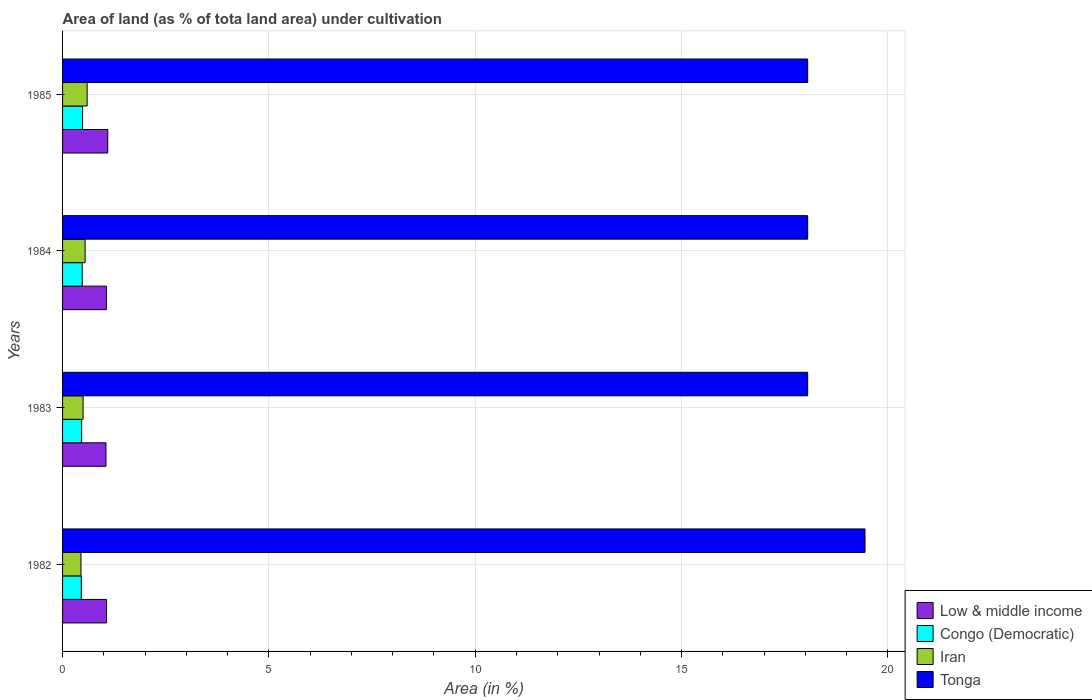How many groups of bars are there?
Provide a succinct answer. 4. Are the number of bars on each tick of the Y-axis equal?
Offer a terse response. Yes. How many bars are there on the 4th tick from the top?
Ensure brevity in your answer.  4. How many bars are there on the 4th tick from the bottom?
Your answer should be very brief. 4. What is the label of the 4th group of bars from the top?
Give a very brief answer. 1982. What is the percentage of land under cultivation in Iran in 1982?
Keep it short and to the point. 0.45. Across all years, what is the maximum percentage of land under cultivation in Congo (Democratic)?
Your answer should be compact. 0.49. Across all years, what is the minimum percentage of land under cultivation in Tonga?
Your answer should be very brief. 18.06. What is the total percentage of land under cultivation in Iran in the graph?
Offer a terse response. 2.09. What is the difference between the percentage of land under cultivation in Congo (Democratic) in 1982 and that in 1984?
Make the answer very short. -0.02. What is the difference between the percentage of land under cultivation in Iran in 1983 and the percentage of land under cultivation in Low & middle income in 1984?
Give a very brief answer. -0.56. What is the average percentage of land under cultivation in Tonga per year?
Offer a terse response. 18.4. In the year 1985, what is the difference between the percentage of land under cultivation in Iran and percentage of land under cultivation in Tonga?
Your answer should be compact. -17.46. In how many years, is the percentage of land under cultivation in Iran greater than 10 %?
Provide a short and direct response. 0. What is the ratio of the percentage of land under cultivation in Congo (Democratic) in 1983 to that in 1985?
Your response must be concise. 0.95. Is the percentage of land under cultivation in Congo (Democratic) in 1982 less than that in 1985?
Your response must be concise. Yes. Is the difference between the percentage of land under cultivation in Iran in 1982 and 1985 greater than the difference between the percentage of land under cultivation in Tonga in 1982 and 1985?
Provide a succinct answer. No. What is the difference between the highest and the second highest percentage of land under cultivation in Tonga?
Your answer should be very brief. 1.39. What is the difference between the highest and the lowest percentage of land under cultivation in Tonga?
Provide a short and direct response. 1.39. In how many years, is the percentage of land under cultivation in Low & middle income greater than the average percentage of land under cultivation in Low & middle income taken over all years?
Offer a very short reply. 1. Is it the case that in every year, the sum of the percentage of land under cultivation in Congo (Democratic) and percentage of land under cultivation in Iran is greater than the sum of percentage of land under cultivation in Low & middle income and percentage of land under cultivation in Tonga?
Ensure brevity in your answer.  No. What does the 1st bar from the top in 1985 represents?
Provide a short and direct response. Tonga. What does the 3rd bar from the bottom in 1983 represents?
Offer a very short reply. Iran. How many bars are there?
Your response must be concise. 16. Are all the bars in the graph horizontal?
Offer a very short reply. Yes. What is the difference between two consecutive major ticks on the X-axis?
Provide a succinct answer. 5. Does the graph contain any zero values?
Give a very brief answer. No. What is the title of the graph?
Give a very brief answer. Area of land (as % of tota land area) under cultivation. What is the label or title of the X-axis?
Your response must be concise. Area (in %). What is the Area (in %) in Low & middle income in 1982?
Your answer should be compact. 1.07. What is the Area (in %) in Congo (Democratic) in 1982?
Make the answer very short. 0.45. What is the Area (in %) of Iran in 1982?
Provide a short and direct response. 0.45. What is the Area (in %) in Tonga in 1982?
Provide a short and direct response. 19.44. What is the Area (in %) in Low & middle income in 1983?
Provide a short and direct response. 1.05. What is the Area (in %) of Congo (Democratic) in 1983?
Keep it short and to the point. 0.46. What is the Area (in %) in Iran in 1983?
Your response must be concise. 0.5. What is the Area (in %) in Tonga in 1983?
Make the answer very short. 18.06. What is the Area (in %) in Low & middle income in 1984?
Offer a terse response. 1.06. What is the Area (in %) of Congo (Democratic) in 1984?
Give a very brief answer. 0.48. What is the Area (in %) in Iran in 1984?
Your answer should be compact. 0.55. What is the Area (in %) of Tonga in 1984?
Offer a terse response. 18.06. What is the Area (in %) of Low & middle income in 1985?
Your response must be concise. 1.09. What is the Area (in %) in Congo (Democratic) in 1985?
Make the answer very short. 0.49. What is the Area (in %) of Iran in 1985?
Keep it short and to the point. 0.6. What is the Area (in %) in Tonga in 1985?
Give a very brief answer. 18.06. Across all years, what is the maximum Area (in %) in Low & middle income?
Offer a very short reply. 1.09. Across all years, what is the maximum Area (in %) in Congo (Democratic)?
Your answer should be very brief. 0.49. Across all years, what is the maximum Area (in %) in Iran?
Offer a terse response. 0.6. Across all years, what is the maximum Area (in %) in Tonga?
Offer a very short reply. 19.44. Across all years, what is the minimum Area (in %) of Low & middle income?
Provide a succinct answer. 1.05. Across all years, what is the minimum Area (in %) in Congo (Democratic)?
Provide a succinct answer. 0.45. Across all years, what is the minimum Area (in %) of Iran?
Make the answer very short. 0.45. Across all years, what is the minimum Area (in %) in Tonga?
Your answer should be compact. 18.06. What is the total Area (in %) of Low & middle income in the graph?
Your answer should be compact. 4.27. What is the total Area (in %) of Congo (Democratic) in the graph?
Keep it short and to the point. 1.88. What is the total Area (in %) of Iran in the graph?
Your answer should be very brief. 2.09. What is the total Area (in %) in Tonga in the graph?
Ensure brevity in your answer.  73.61. What is the difference between the Area (in %) in Low & middle income in 1982 and that in 1983?
Give a very brief answer. 0.01. What is the difference between the Area (in %) of Congo (Democratic) in 1982 and that in 1983?
Make the answer very short. -0.01. What is the difference between the Area (in %) of Iran in 1982 and that in 1983?
Provide a short and direct response. -0.05. What is the difference between the Area (in %) of Tonga in 1982 and that in 1983?
Keep it short and to the point. 1.39. What is the difference between the Area (in %) in Low & middle income in 1982 and that in 1984?
Ensure brevity in your answer.  0. What is the difference between the Area (in %) in Congo (Democratic) in 1982 and that in 1984?
Offer a very short reply. -0.02. What is the difference between the Area (in %) of Iran in 1982 and that in 1984?
Make the answer very short. -0.1. What is the difference between the Area (in %) in Tonga in 1982 and that in 1984?
Provide a succinct answer. 1.39. What is the difference between the Area (in %) of Low & middle income in 1982 and that in 1985?
Ensure brevity in your answer.  -0.03. What is the difference between the Area (in %) in Congo (Democratic) in 1982 and that in 1985?
Provide a succinct answer. -0.03. What is the difference between the Area (in %) of Iran in 1982 and that in 1985?
Provide a succinct answer. -0.15. What is the difference between the Area (in %) of Tonga in 1982 and that in 1985?
Provide a succinct answer. 1.39. What is the difference between the Area (in %) of Low & middle income in 1983 and that in 1984?
Give a very brief answer. -0.01. What is the difference between the Area (in %) of Congo (Democratic) in 1983 and that in 1984?
Give a very brief answer. -0.01. What is the difference between the Area (in %) in Iran in 1983 and that in 1984?
Provide a succinct answer. -0.05. What is the difference between the Area (in %) of Low & middle income in 1983 and that in 1985?
Your answer should be compact. -0.04. What is the difference between the Area (in %) in Congo (Democratic) in 1983 and that in 1985?
Your answer should be compact. -0.02. What is the difference between the Area (in %) of Iran in 1983 and that in 1985?
Make the answer very short. -0.1. What is the difference between the Area (in %) in Tonga in 1983 and that in 1985?
Offer a very short reply. 0. What is the difference between the Area (in %) in Low & middle income in 1984 and that in 1985?
Offer a very short reply. -0.03. What is the difference between the Area (in %) of Congo (Democratic) in 1984 and that in 1985?
Give a very brief answer. -0.01. What is the difference between the Area (in %) in Iran in 1984 and that in 1985?
Provide a succinct answer. -0.05. What is the difference between the Area (in %) in Tonga in 1984 and that in 1985?
Provide a short and direct response. 0. What is the difference between the Area (in %) in Low & middle income in 1982 and the Area (in %) in Congo (Democratic) in 1983?
Ensure brevity in your answer.  0.6. What is the difference between the Area (in %) in Low & middle income in 1982 and the Area (in %) in Iran in 1983?
Provide a short and direct response. 0.57. What is the difference between the Area (in %) in Low & middle income in 1982 and the Area (in %) in Tonga in 1983?
Give a very brief answer. -16.99. What is the difference between the Area (in %) of Congo (Democratic) in 1982 and the Area (in %) of Iran in 1983?
Make the answer very short. -0.04. What is the difference between the Area (in %) in Congo (Democratic) in 1982 and the Area (in %) in Tonga in 1983?
Your response must be concise. -17.6. What is the difference between the Area (in %) of Iran in 1982 and the Area (in %) of Tonga in 1983?
Offer a terse response. -17.61. What is the difference between the Area (in %) in Low & middle income in 1982 and the Area (in %) in Congo (Democratic) in 1984?
Ensure brevity in your answer.  0.59. What is the difference between the Area (in %) in Low & middle income in 1982 and the Area (in %) in Iran in 1984?
Give a very brief answer. 0.52. What is the difference between the Area (in %) of Low & middle income in 1982 and the Area (in %) of Tonga in 1984?
Your response must be concise. -16.99. What is the difference between the Area (in %) in Congo (Democratic) in 1982 and the Area (in %) in Iran in 1984?
Give a very brief answer. -0.09. What is the difference between the Area (in %) of Congo (Democratic) in 1982 and the Area (in %) of Tonga in 1984?
Make the answer very short. -17.6. What is the difference between the Area (in %) of Iran in 1982 and the Area (in %) of Tonga in 1984?
Give a very brief answer. -17.61. What is the difference between the Area (in %) of Low & middle income in 1982 and the Area (in %) of Congo (Democratic) in 1985?
Offer a terse response. 0.58. What is the difference between the Area (in %) of Low & middle income in 1982 and the Area (in %) of Iran in 1985?
Give a very brief answer. 0.47. What is the difference between the Area (in %) in Low & middle income in 1982 and the Area (in %) in Tonga in 1985?
Your answer should be compact. -16.99. What is the difference between the Area (in %) of Congo (Democratic) in 1982 and the Area (in %) of Iran in 1985?
Your answer should be very brief. -0.14. What is the difference between the Area (in %) of Congo (Democratic) in 1982 and the Area (in %) of Tonga in 1985?
Keep it short and to the point. -17.6. What is the difference between the Area (in %) of Iran in 1982 and the Area (in %) of Tonga in 1985?
Offer a very short reply. -17.61. What is the difference between the Area (in %) of Low & middle income in 1983 and the Area (in %) of Congo (Democratic) in 1984?
Your answer should be very brief. 0.58. What is the difference between the Area (in %) in Low & middle income in 1983 and the Area (in %) in Iran in 1984?
Provide a succinct answer. 0.51. What is the difference between the Area (in %) of Low & middle income in 1983 and the Area (in %) of Tonga in 1984?
Your answer should be very brief. -17. What is the difference between the Area (in %) in Congo (Democratic) in 1983 and the Area (in %) in Iran in 1984?
Your answer should be compact. -0.08. What is the difference between the Area (in %) of Congo (Democratic) in 1983 and the Area (in %) of Tonga in 1984?
Your response must be concise. -17.59. What is the difference between the Area (in %) in Iran in 1983 and the Area (in %) in Tonga in 1984?
Provide a short and direct response. -17.56. What is the difference between the Area (in %) of Low & middle income in 1983 and the Area (in %) of Congo (Democratic) in 1985?
Your response must be concise. 0.57. What is the difference between the Area (in %) in Low & middle income in 1983 and the Area (in %) in Iran in 1985?
Offer a very short reply. 0.46. What is the difference between the Area (in %) of Low & middle income in 1983 and the Area (in %) of Tonga in 1985?
Your response must be concise. -17. What is the difference between the Area (in %) in Congo (Democratic) in 1983 and the Area (in %) in Iran in 1985?
Provide a short and direct response. -0.13. What is the difference between the Area (in %) in Congo (Democratic) in 1983 and the Area (in %) in Tonga in 1985?
Ensure brevity in your answer.  -17.59. What is the difference between the Area (in %) in Iran in 1983 and the Area (in %) in Tonga in 1985?
Your answer should be very brief. -17.56. What is the difference between the Area (in %) in Low & middle income in 1984 and the Area (in %) in Congo (Democratic) in 1985?
Ensure brevity in your answer.  0.58. What is the difference between the Area (in %) in Low & middle income in 1984 and the Area (in %) in Iran in 1985?
Offer a very short reply. 0.47. What is the difference between the Area (in %) of Low & middle income in 1984 and the Area (in %) of Tonga in 1985?
Your answer should be compact. -16.99. What is the difference between the Area (in %) of Congo (Democratic) in 1984 and the Area (in %) of Iran in 1985?
Provide a succinct answer. -0.12. What is the difference between the Area (in %) in Congo (Democratic) in 1984 and the Area (in %) in Tonga in 1985?
Your answer should be compact. -17.58. What is the difference between the Area (in %) in Iran in 1984 and the Area (in %) in Tonga in 1985?
Give a very brief answer. -17.51. What is the average Area (in %) in Low & middle income per year?
Make the answer very short. 1.07. What is the average Area (in %) of Congo (Democratic) per year?
Make the answer very short. 0.47. What is the average Area (in %) of Iran per year?
Ensure brevity in your answer.  0.52. What is the average Area (in %) of Tonga per year?
Ensure brevity in your answer.  18.4. In the year 1982, what is the difference between the Area (in %) in Low & middle income and Area (in %) in Congo (Democratic)?
Your response must be concise. 0.61. In the year 1982, what is the difference between the Area (in %) of Low & middle income and Area (in %) of Iran?
Your response must be concise. 0.62. In the year 1982, what is the difference between the Area (in %) in Low & middle income and Area (in %) in Tonga?
Your answer should be compact. -18.38. In the year 1982, what is the difference between the Area (in %) in Congo (Democratic) and Area (in %) in Iran?
Offer a very short reply. 0.01. In the year 1982, what is the difference between the Area (in %) in Congo (Democratic) and Area (in %) in Tonga?
Offer a very short reply. -18.99. In the year 1982, what is the difference between the Area (in %) of Iran and Area (in %) of Tonga?
Provide a short and direct response. -19. In the year 1983, what is the difference between the Area (in %) of Low & middle income and Area (in %) of Congo (Democratic)?
Your answer should be very brief. 0.59. In the year 1983, what is the difference between the Area (in %) in Low & middle income and Area (in %) in Iran?
Provide a succinct answer. 0.55. In the year 1983, what is the difference between the Area (in %) of Low & middle income and Area (in %) of Tonga?
Keep it short and to the point. -17. In the year 1983, what is the difference between the Area (in %) of Congo (Democratic) and Area (in %) of Iran?
Provide a short and direct response. -0.03. In the year 1983, what is the difference between the Area (in %) of Congo (Democratic) and Area (in %) of Tonga?
Provide a succinct answer. -17.59. In the year 1983, what is the difference between the Area (in %) in Iran and Area (in %) in Tonga?
Your answer should be very brief. -17.56. In the year 1984, what is the difference between the Area (in %) of Low & middle income and Area (in %) of Congo (Democratic)?
Provide a succinct answer. 0.59. In the year 1984, what is the difference between the Area (in %) of Low & middle income and Area (in %) of Iran?
Make the answer very short. 0.52. In the year 1984, what is the difference between the Area (in %) of Low & middle income and Area (in %) of Tonga?
Offer a terse response. -16.99. In the year 1984, what is the difference between the Area (in %) of Congo (Democratic) and Area (in %) of Iran?
Your response must be concise. -0.07. In the year 1984, what is the difference between the Area (in %) of Congo (Democratic) and Area (in %) of Tonga?
Keep it short and to the point. -17.58. In the year 1984, what is the difference between the Area (in %) in Iran and Area (in %) in Tonga?
Ensure brevity in your answer.  -17.51. In the year 1985, what is the difference between the Area (in %) in Low & middle income and Area (in %) in Congo (Democratic)?
Your answer should be very brief. 0.61. In the year 1985, what is the difference between the Area (in %) in Low & middle income and Area (in %) in Iran?
Your answer should be compact. 0.5. In the year 1985, what is the difference between the Area (in %) in Low & middle income and Area (in %) in Tonga?
Your answer should be very brief. -16.96. In the year 1985, what is the difference between the Area (in %) of Congo (Democratic) and Area (in %) of Iran?
Your answer should be compact. -0.11. In the year 1985, what is the difference between the Area (in %) of Congo (Democratic) and Area (in %) of Tonga?
Ensure brevity in your answer.  -17.57. In the year 1985, what is the difference between the Area (in %) in Iran and Area (in %) in Tonga?
Provide a short and direct response. -17.46. What is the ratio of the Area (in %) in Low & middle income in 1982 to that in 1983?
Make the answer very short. 1.01. What is the ratio of the Area (in %) of Iran in 1982 to that in 1983?
Keep it short and to the point. 0.9. What is the ratio of the Area (in %) in Congo (Democratic) in 1982 to that in 1984?
Give a very brief answer. 0.95. What is the ratio of the Area (in %) of Iran in 1982 to that in 1984?
Your response must be concise. 0.82. What is the ratio of the Area (in %) in Congo (Democratic) in 1982 to that in 1985?
Your response must be concise. 0.94. What is the ratio of the Area (in %) in Iran in 1982 to that in 1985?
Your answer should be very brief. 0.75. What is the ratio of the Area (in %) in Low & middle income in 1983 to that in 1984?
Make the answer very short. 0.99. What is the ratio of the Area (in %) of Congo (Democratic) in 1983 to that in 1984?
Your answer should be compact. 0.97. What is the ratio of the Area (in %) of Iran in 1983 to that in 1984?
Keep it short and to the point. 0.91. What is the ratio of the Area (in %) in Tonga in 1983 to that in 1984?
Offer a terse response. 1. What is the ratio of the Area (in %) in Low & middle income in 1983 to that in 1985?
Your answer should be compact. 0.96. What is the ratio of the Area (in %) of Congo (Democratic) in 1983 to that in 1985?
Give a very brief answer. 0.95. What is the ratio of the Area (in %) in Iran in 1983 to that in 1985?
Make the answer very short. 0.84. What is the ratio of the Area (in %) in Tonga in 1983 to that in 1985?
Make the answer very short. 1. What is the ratio of the Area (in %) in Low & middle income in 1984 to that in 1985?
Your answer should be compact. 0.97. What is the ratio of the Area (in %) in Congo (Democratic) in 1984 to that in 1985?
Make the answer very short. 0.98. What is the ratio of the Area (in %) of Iran in 1984 to that in 1985?
Keep it short and to the point. 0.92. What is the ratio of the Area (in %) in Tonga in 1984 to that in 1985?
Offer a terse response. 1. What is the difference between the highest and the second highest Area (in %) of Low & middle income?
Provide a succinct answer. 0.03. What is the difference between the highest and the second highest Area (in %) in Congo (Democratic)?
Offer a terse response. 0.01. What is the difference between the highest and the second highest Area (in %) of Iran?
Make the answer very short. 0.05. What is the difference between the highest and the second highest Area (in %) in Tonga?
Your answer should be very brief. 1.39. What is the difference between the highest and the lowest Area (in %) in Low & middle income?
Provide a short and direct response. 0.04. What is the difference between the highest and the lowest Area (in %) of Congo (Democratic)?
Provide a short and direct response. 0.03. What is the difference between the highest and the lowest Area (in %) in Iran?
Keep it short and to the point. 0.15. What is the difference between the highest and the lowest Area (in %) in Tonga?
Offer a terse response. 1.39. 